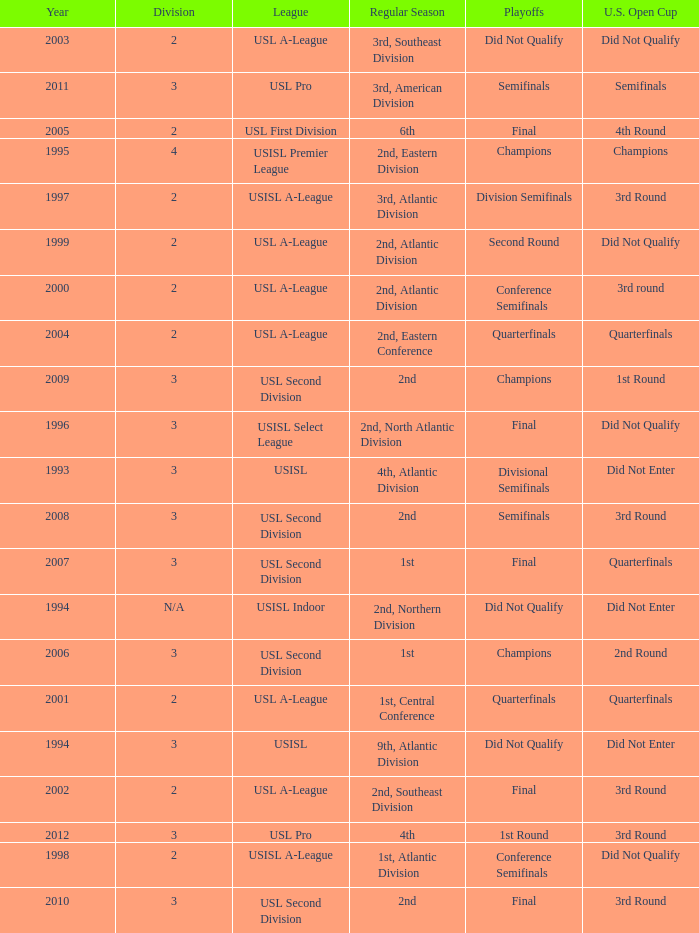How many division  did not qualify for u.s. open cup in 2003 2.0. 